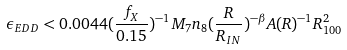Convert formula to latex. <formula><loc_0><loc_0><loc_500><loc_500>\epsilon _ { E D D } < 0 . 0 0 4 4 ( \frac { f _ { X } } { 0 . 1 5 } ) ^ { - 1 } M _ { 7 } n _ { 8 } ( \frac { R } { R _ { I N } } ) ^ { - \beta } A ( R ) ^ { - 1 } R _ { 1 0 0 } ^ { 2 }</formula> 